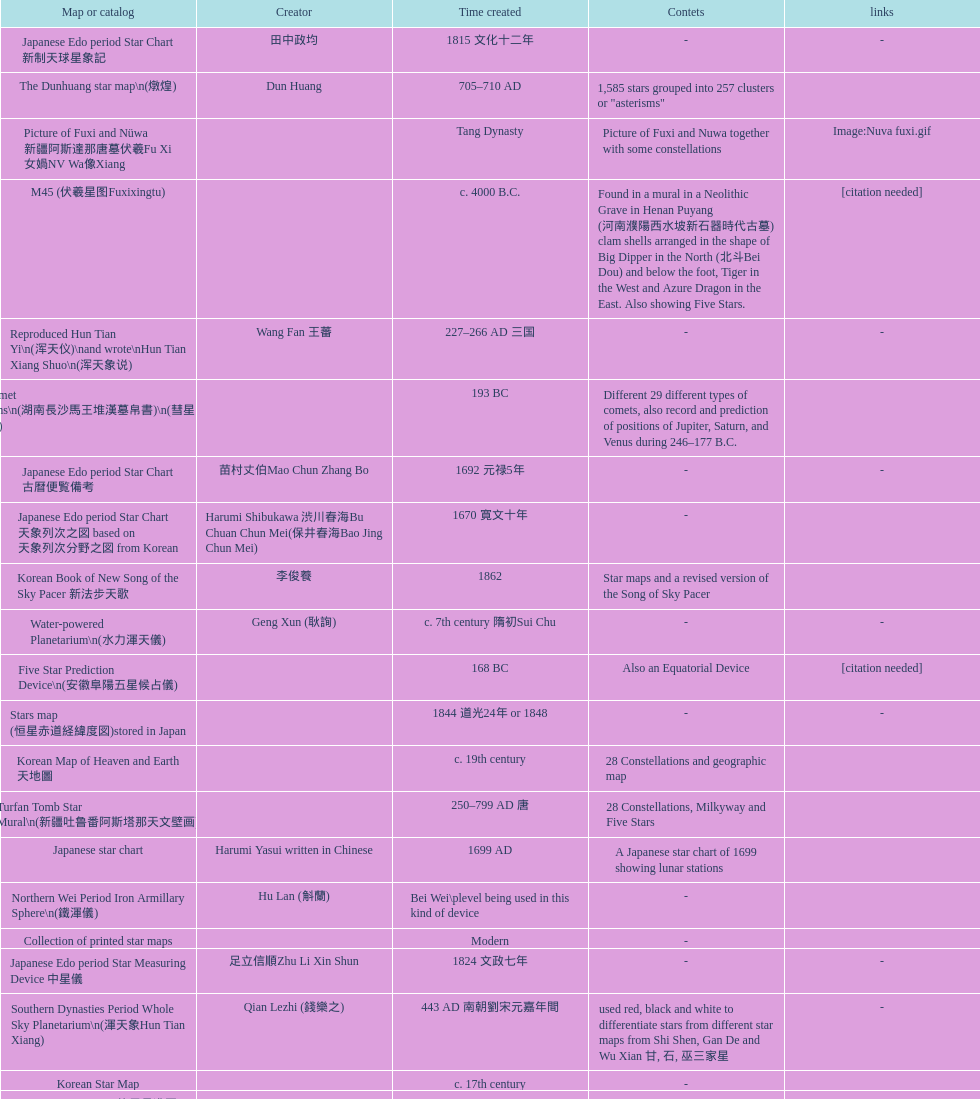Write the full table. {'header': ['Map or catalog', 'Creator', 'Time created', 'Contets', 'links'], 'rows': [['Japanese Edo period Star Chart 新制天球星象記', '田中政均', '1815 文化十二年', '-', '-'], ['The Dunhuang star map\\n(燉煌)', 'Dun Huang', '705–710 AD', '1,585 stars grouped into 257 clusters or "asterisms"', ''], ['Picture of Fuxi and Nüwa 新疆阿斯達那唐墓伏羲Fu Xi 女媧NV Wa像Xiang', '', 'Tang Dynasty', 'Picture of Fuxi and Nuwa together with some constellations', 'Image:Nuva fuxi.gif'], ['M45 (伏羲星图Fuxixingtu)', '', 'c. 4000 B.C.', 'Found in a mural in a Neolithic Grave in Henan Puyang (河南濮陽西水坡新石器時代古墓) clam shells arranged in the shape of Big Dipper in the North (北斗Bei Dou) and below the foot, Tiger in the West and Azure Dragon in the East. Also showing Five Stars.', '[citation needed]'], ['Reproduced Hun Tian Yi\\n(浑天仪)\\nand wrote\\nHun Tian Xiang Shuo\\n(浑天象说)', 'Wang Fan 王蕃', '227–266 AD 三国', '-', '-'], ['Han Comet Diagrams\\n(湖南長沙馬王堆漢墓帛書)\\n(彗星圖Meng xing Tu)', '', '193 BC', 'Different 29 different types of comets, also record and prediction of positions of Jupiter, Saturn, and Venus during 246–177 B.C.', ''], ['Japanese Edo period Star Chart 古暦便覧備考', '苗村丈伯Mao Chun Zhang Bo', '1692 元禄5年', '-', '-'], ['Japanese Edo period Star Chart 天象列次之図 based on 天象列次分野之図 from Korean', 'Harumi Shibukawa 渋川春海Bu Chuan Chun Mei(保井春海Bao Jing Chun Mei)', '1670 寛文十年', '-', ''], ['Korean Book of New Song of the Sky Pacer 新法步天歌', '李俊養', '1862', 'Star maps and a revised version of the Song of Sky Pacer', ''], ['Water-powered Planetarium\\n(水力渾天儀)', 'Geng Xun (耿詢)', 'c. 7th century 隋初Sui Chu', '-', '-'], ['Five Star Prediction Device\\n(安徽阜陽五星候占儀)', '', '168 BC', 'Also an Equatorial Device', '[citation needed]'], ['Stars map (恒星赤道経緯度図)stored in Japan', '', '1844 道光24年 or 1848', '-', '-'], ['Korean Map of Heaven and Earth 天地圖', '', 'c. 19th century', '28 Constellations and geographic map', ''], ['Turfan Tomb Star Mural\\n(新疆吐鲁番阿斯塔那天文壁画)', '', '250–799 AD 唐', '28 Constellations, Milkyway and Five Stars', ''], ['Japanese star chart', 'Harumi Yasui written in Chinese', '1699 AD', 'A Japanese star chart of 1699 showing lunar stations', ''], ['Northern Wei Period Iron Armillary Sphere\\n(鐵渾儀)', 'Hu Lan (斛蘭)', 'Bei Wei\\plevel being used in this kind of device', '-', ''], ['Collection of printed star maps', '', 'Modern', '-', ''], ['Japanese Edo period Star Measuring Device 中星儀', '足立信順Zhu Li Xin Shun', '1824 文政七年', '-', '-'], ['Southern Dynasties Period Whole Sky Planetarium\\n(渾天象Hun Tian Xiang)', 'Qian Lezhi (錢樂之)', '443 AD 南朝劉宋元嘉年間', 'used red, black and white to differentiate stars from different star maps from Shi Shen, Gan De and Wu Xian 甘, 石, 巫三家星', '-'], ['Korean Star Map', '', 'c. 17th century', '-', ''], ['Japanese Star Chart 格子月進図', '', '1324', 'Similar to Su Song Star Chart, original burned in air raids during World War II, only pictures left. Reprinted in 1984 by 佐佐木英治', ''], ['Korean Star Map 天象列次分野之図 in Kanji', '', 'c. 19th century', 'Printed map showing Chinese names of stars and constellations', '[18]'], ['Tangut Khara-Khoto (The Black City) Star Map 西夏黑水城星圖', '', '940 AD', 'A typical Qian Lezhi Style Star Map', '-'], ['Korean Star Map Stone', '', 'c. 17th century', '-', ''], ['Chinese Star map', 'John Reeves esq', '1819 AD', 'Printed map showing Chinese names of stars and constellations', ''], ['Wikipedia Star maps', '', 'Modern', '-', 'zh:華蓋星'], ['Equatorial Armillary Sphere\\n(赤道式渾儀)', 'Luo Xiahong (落下閎)', '104 BC 西漢武帝時', 'lost', '[citation needed]'], ['Korean Book of Stars 經星', '', 'c. 19th century', 'Several star maps', ''], ['Chanshu Star Chart (明常熟石刻天文圖)', '', '1506', 'Based on Suzhou Star Chart, Northern Sky observed at 36.8 degrees North Latitude, 1466 stars grouped into 284 asterism', '-'], ['Ming Dynasty General Star Map (赤道南北兩總星圖)', 'Xu Guang ci 徐光啟 and Adam Schall von Bell Tang Ruo Wang湯若望', '1634', '-', ''], ['The Chinese Sky during the Han Constellating Stars and Society', 'Sun Xiaochun and Jacob Kistemaker', '1997 AD', 'An attempt to recreate night sky seen by Chinese 2000 years ago', ''], ['Song Dynasty Bronze Armillary Sphere 北宋天文院黄道渾儀', 'Shu Yijian 舒易簡, Yu Yuan 于渊, Zhou Cong 周琮', '宋皇祐年中', 'Similar to the Armillary by Tang Dynasty Liang Lingzan 梁令瓚 and Yi Xing 一行', '-'], ['First remark of a constellation in observation in Korean history', '', '49 BC 혁거세 거서간 9년', "The star 'Pae'(a kind of comet) appeared in the constellation Wang Rang", 'Samguk Sagi'], ['Ming Ancient Star Chart 北京隆福寺(古星圖)', '', 'c. 1453 明代', '1420 Stars, possibly based on old star maps from Tang Dynasty', ''], ['Big Dipper\\n(山東嘉祥武梁寺石刻北斗星)', '', '–', 'showing stars in Big Dipper', ''], ['修真內外火侯全圖 Huo Hou Tu', 'Xi Chun Sheng Chong Hui\\p2005 redrawn, original unknown', 'illustrations of Milkyway and star maps, Chinese constellations in Taoism view', '', ''], ['Star Chart 清蒙文石刻(欽天監繪製天文圖) in Mongolia', '', '1727–1732 AD', '1550 stars grouped into 270 starisms.', ''], ['Japanese Edo period Star Chart 天球図', '坂部廣胖', '1816 文化十三年', '-', '-'], ['Korean Tomb', '', 'c. late 14th century', 'Big Dipper', ''], ['Zhou Tian Xuan Ji Tu (周天璇玑图) and He He Si Xiang Tu (和合四象圖) in Xing Ming Gui Zhi (性命圭旨)', 'by 尹真人高第弟子 published by 余永宁', '1615', 'Drawings of Armillary Sphere and four Chinese Celestial Animals with some notes. Related to Taoism.', ''], ['Sky Map\\n(浑天图)\\nand\\nHun Tian Yi Shuo\\n(浑天仪说)', 'Lu Ji (陆绩)', '187–219 AD 三国', '-', '-'], ['Japanese Edo period Star Chart 経緯簡儀用法', '藤岡有貞', '1845 弘化２年', '-', '-'], ['Eastern Han Celestial Globe and star maps\\n(浑天仪)\\n(渾天儀圖注,浑天仪图注)\\n(靈憲,灵宪)', 'Zhang Heng (张衡)', '117 AD', '-', '-'], ['Star Map with illustrations for Xingguans', '坐井★观星Zuo Jing Guan Xing', 'Modern', 'illustrations for cylindrical and circular polar maps', ''], ['28 Xu Star map and catalog', '-', 'Modern', 'Stars around ecliptic', ''], ['Japanese Star Chart 改正天文図説', '', 'unknown', 'Included stars from Harumi Shibukawa', ''], ['Stellarium Chinese and Korean Sky Culture', 'G.S.K. Lee; Jeong, Tae-Min(jtm71); Yu-Pu Wang (evanzxcv)', 'Modern', 'Major Xingguans and Star names', ''], ['Rock Star Chart 清代天文石', '', 'c. 18th century', 'A Star Chart and general Astronomy Text', ''], ['Japanese Edo period Star Chart 天象管鈔 天体図 (天文星象図解)', '長久保赤水', '1824 文政七年', '-', ''], ['Star maps', '', 'Recent', 'Chinese 28 Constellation with Chinese and Japanese captions', ''], ['Ancient Star Map 先天图 by 陈抟Chen Tuan', '', 'c. 11th Chen Tuan 宋Song', 'Perhaps based on studying of Puyong Ancient Star Map', 'Lost'], ['Song Dynasty Water-powered Planetarium 宋代 水运仪象台', 'Su Song 蘇頌 and Han Gonglian 韩公廉', 'c. 11th century', '-', ''], ['Prajvalonisa Vjrabhairava Padvinasa-sri-dharani Scroll found in Japan 熾盛光佛頂大威德銷災吉祥陀羅尼經卷首扉畫', '', '972 AD 北宋開寶五年', 'Chinese 28 Constellations and Western Zodiac', '-'], ['Japanese Edo period Star Chart 方円星図,方圓星図 and 増補分度星図方図', '石坂常堅', '1826b文政9年', '-', '-'], ['Fuxi 64 gua 28 xu wood carving 天水市卦台山伏羲六十四卦二十八宿全图', '', 'modern', '-', '-'], ['HNSKY Korean/Chinese Supplement', 'Jeong, Tae-Min(jtm71)/Chuang_Siau_Chin', 'Modern', 'Korean supplement is based on CheonSangYeulChaBunYaZiDo (B.C.100 ~ A.D.100)', ''], ['First Ecliptic Armillary Sphere\\n(黄道仪Huang Dao Yi)', 'Jia Kui 贾逵', '30–101 AD 东汉永元十五年', '-', '-'], ['Korean Star Maps, North and South to the Eclliptic 黃道南北恒星圖', '', '1742', '-', ''], ['Sky in Google Earth KML', '', 'Modern', 'Attempts to show Chinese Star Maps on Google Earth', ''], ['Hun Tian Yi Tong Xing Xiang Quan Tu, Suzhou Star Chart (蘇州石刻天文圖),淳祐天文図', 'Huang Shang (黃裳)', 'created in 1193, etched to stone in 1247 by Wang Zhi Yuan 王致遠', '1434 Stars grouped into 280 Asterisms in Northern Sky map', ''], ['Reproduction of an ancient device 璇璣玉衡', 'Dai Zhen 戴震', '1723–1777 AD', 'based on ancient record and his own interpretation', 'Could be similar to'], ['AEEA Star maps', '', 'Modern', 'Good reconstruction and explanation of Chinese constellations', ''], ['Japanese Star Chart 梅園星図', '高橋景保', '-', '-', ''], ['Warring States Period grave lacquer box\\n(戰國初年湖北隨縣擂鼓墩曾侯乙墓漆箱)', '', 'c. 5th century BC', 'Indicated location of Big Dipper and 28 Constellations by characters', ''], ['Japanese Star Chart', '伊能忠誨', 'c. 19th century', '-', '-'], ['Whole Sky Star Maps\\n(全天星圖Quan Tian Xing Tu)', 'Chen Zhuo (陳卓)', 'c. 270 AD 西晉初Xi Jin Chu', 'A Unified Constellation System. Star maps containing 1464 stars in 284 Constellations, written astrology text', '-'], ['Japanese Edo period Star Chart 天文成象Tian Wen Cheng xiang', '(渋川昔尹She Chuan Xi Yin) (保井昔尹Bao Jing Xi Yin)', '1699 元禄十二年', 'including Stars from Wu Shien (44 Constellation, 144 stars) in yellow; Gan De (118 Constellations, 511 stars) in black; Shi Shen (138 Constellations, 810 stars) in red and Harumi Shibukawa (61 Constellations, 308 stars) in blue;', ''], ['Japanese Star Chart 瀧谷寺 天之図', '', 'c. 14th or 15th centuries 室町中期以前', '-', ''], ['Stars South of Equator, Stars North of Equator (赤道南恆星圖,赤道北恆星圖)', '', '1875～1908 清末光緒年間', 'Similar to Ming Dynasty General Star Map', ''], ['Shi Shen astronomy\\n(石申天文Shi Shen Tian wen)\\naka. (石氏星经 Shi Shi Xing Jing)', 'Shi Shen (石申)', 'c. 350 B.C.', '138 Constellations and the name of 810 stars, location of 121 stars, some said it contains The 28 Lunar Ecliptic Constellations, 62 Central Constellations and 30 Outer Constellations', '[citation needed]'], ['Han Grave Mural Star Chart\\n(洛阳西汉墓壁画)\\n(星象图Xing Xiang Tu)', '', 'c. 1st century', 'Sun, Moon and ten other star charts', ''], ['Five Star Charts (新儀象法要)', 'Su Song 蘇頌', '1094 AD', '1464 stars grouped into 283 asterisms', 'Image:Su Song Star Map 1.JPG\\nImage:Su Song Star Map 2.JPG'], ['Sky Map', 'Yu Xi Dao Ren 玉溪道人', '1987', 'Star Map with captions', ''], ['Ming Dynasty Star Map (渾蓋通憲圖說)', 'Matteo Ricci 利玛窦Li Ma Dou, recorded by Li Zhizao 李之藻', 'c. 1550', '-', ''], ['Japanese Edo period Star Chart 昊天図説詳解', '佐藤祐之', '1824 文政七年', '-', '-'], ['Korean version of 28 Constellation 列宿圖', '', 'c. 19th century', '28 Constellations, some named differently from their Chinese counterparts', ''], ['Korean Complete Star Map (渾天全圖)', '', 'c. 18th century', '-', ''], ['Yuan Dynasty Simplified Armillary Sphere 元代簡儀', 'Guo Shou Jing 郭守敬', '1276–1279', 'Further simplied version of Song Dynasty Device', ''], ['Qing Dynasty Star Catalog (儀象考成,仪象考成)恒星表 and Star Map 黄道南北両星総図', 'Yun Lu 允禄 and Ignatius Kogler 戴进贤Dai Jin Xian 戴進賢, a German', 'Device made in 1744, book completed in 1757 清乾隆年间', '300 Constellations and 3083 Stars. Referenced Star Catalogue published by John Flamsteed', ''], ['SinoSky Beta 2.0', '', '2002', 'A computer program capable of showing Chinese Xingguans alongside with western constellations, lists about 700 stars with Chinese names.', ''], ['Wu Xian Star Map\\n(商巫咸星圖Shang wu Jian xing Tu)', 'Wu Xian', 'c. 1000 BC', 'Contained 44 Central and Outer constellations totalling 141 stars', '[citation needed]'], ['Lingtai Miyuan\\n(靈台秘苑)', 'Yu Jicai (庾季才) and Zhou Fen (周墳)', '604 AD 隋Sui', 'incorporated star maps from different sources', '-'], ['Korean Astronomy Book "Selected and Systematized Astronomy Notes" 天文類抄', '', '1623~1649', 'Contained some star maps', ''], ['Equatorial Armillary Sphere\\n(渾儀Hun Xi)', 'Kong Ting (孔挺)', '323 AD 東晉 前趙光初六年', 'level being used in this kind of device', '-'], ['Star Chart in a Dao Temple 玉皇山道觀星圖', '', '1940 AD', '-', '-'], ['Japanese Edo period Star Chart', '鈴木世孝', '1824 文政七年', '-', '-'], ['Korean star map in stone', '', '1687', '-', ''], ['Star Chart 五代吳越文穆王前元瓘墓石刻星象圖', '', '941–960 AD', '-', ''], ['Japanese Edo period Star Chart 天経或問註解図巻\u3000下', '入江脩敬Ru Jiang YOu Jing', '1750 寛延3年', '-', '-'], ['Japanese Star Map 天象一覧図 in Kanji', '桜田虎門', '1824 AD 文政７年', 'Printed map showing Chinese names of stars and constellations', ''], ['Japanese Edo period Star Chart 星図歩天歌', '小島好謙 and 鈴木世孝', '1824 文政七年', '-', '-'], ['Qing Dynasty Star Catalog (儀象考成續編)星表', '', '1844', 'Appendix to Yi Xian Kao Cheng, listed 3240 stars (added 163, removed 6)', ''], ['Northern Wei Grave Dome Star Map\\n(河南洛陽北魏墓頂星圖)', '', '526 AD 北魏孝昌二年', 'about 300 stars, including the Big Dipper, some stars are linked by straight lines to form constellation. The Milky Way is also shown.', ''], ['Japanese Edo period Star Chart 分野星図', '高塚福昌, 阿部比輔, 上条景弘', '1849 嘉永2年', '-', '-'], ['Japanese Edo period Illustration of a Star Measuring Device 平天儀図解', 'Yan Qiao Shan Bing Heng 岩橋善兵衛', '1802 Xiang He Er Nian 享和二年', '-', 'The device could be similar to'], ['Kitora Kofun 法隆寺FaLong Si\u3000キトラ古墳 in Japan', '', 'c. late 7th century – early 8th century', 'Detailed whole sky map', ''], ['Han Dynasty Nanyang Stone Engraving\\n(河南南阳汉石刻画)\\n(行雨图Xing Yu Tu)', '', 'c. 1st century', 'Depicted five stars forming a cross', ''], ['天象列次分野之図(Cheonsang Yeolcha Bunyajido)', '', '1395', 'Korean versions of Star Map in Stone. It was made in Chosun Dynasty and the constellation names were written in Chinese letter. The constellations as this was found in Japanese later. Contained 1,464 stars.', ''], ['Tang Dynasty Whole Sky Ecliptic Armillary Sphere\\n(渾天黃道儀)', 'Li Chunfeng 李淳風', '667 AD 貞觀七年', 'including Elliptic and Moon orbit, in addition to old equatorial design', '-'], ['Ming Dynasty Planetarium Machine (渾象 Hui Xiang)', '', 'c. 17th century', 'Ecliptic, Equator, and dividers of 28 constellation', ''], ['Jingban Tianwen Quantu by Ma Junliang 马俊良', '', '1780–90 AD', 'mapping nations to the sky', ''], ['Korean Star Map Cube 方星圖', 'Italian Missionary Philippus Maria Grimardi 閔明我 (1639~1712)', 'c. early 18th century', '-', ''], ['North Sky Map 清嘉庆年间Huang Dao Zhong Xi He Tu(黄道中西合图)', 'Xu Choujun 徐朝俊', '1807 AD', 'More than 1000 stars and the 28 consellation', ''], ['Japanese Late Edo period Star Chart 天文図屏風', '遠藤盛俊', 'late Edo Period 江戸時代後期', '-', '-'], ['Japanese Star Chart 天体図', '三浦梅園', '-', '-', '-'], ['Korean Star maps: Star Map South to the Ecliptic 黃道南恒星圖 and Star Map South to the Ecliptic 黃道北恒星圖', '', 'c. 19th century', 'Perhaps influenced by Adam Schall von Bell Tang Ruo wang 湯若望 (1591–1666) and P. Ignatius Koegler 戴進賢 (1680–1748)', ''], ["Star Map in a woman's grave (江西德安 南宋周氏墓星相图)", '', '1127–1279 AD', 'Milky Way and 57 other stars.', ''], ['Song Dynasty Bronze Armillary Sphere 北宋至道銅渾儀', 'Han Xianfu 韓顯符', '1006 AD 宋道元年十二月', 'Similar to the Simplified Armillary by Kong Ting 孔挺, 晁崇 Chao Chong, 斛蘭 Hu Lan', '-'], ['Star Chart preserved in Japan based on a book from China 天経或問', 'You Zi liu 游子六', '1730 AD 江戸時代 享保15年', 'A Northern Sky Chart in Chinese', ''], ['Treatise on Astrology of the Kaiyuan Era\\n(開元占経,开元占经Kai Yuan zhang Jing)', 'Gautama Siddha', '713 AD –', 'Collection of the three old star charts from Shi Shen, Gan De and Wu Xian. One of the most renowned collection recognized academically.', '-'], ['Liao Dynasty Tomb Dome Star Map 遼宣化张世卿墓頂星圖', '', '1116 AD 遼天庆六年', 'shown both the Chinese 28 Constellation encircled by Babylonian Zodiac', ''], ['Korean Star Chart 渾天図', '朴?', '-', '-', '-'], ['Tang Dynasty Indian Horoscope Chart\\n(梵天火羅九曜)', 'Yixing Priest 一行和尚 (张遂)\\pZhang Sui\\p683–727 AD', 'simple diagrams of the 28 Constellation', '', ''], ['Song Dynasty Armillary Sphere 北宋簡化渾儀', 'Shen Kuo 沈括 and Huangfu Yu 皇甫愈', '1089 AD 熙寧七年', 'Simplied version of Tang Dynasty Device, removed the rarely used moon orbit.', '-'], ['Tian Wun Tu (天问图)', 'Xiao Yun Cong 萧云从', 'c. 1600', 'Contained mapping of 12 constellations and 12 animals', ''], ['The Celestial Globe 清康熙 天體儀', 'Ferdinand Verbiest 南懷仁', '1673', '1876 stars grouped into 282 asterisms', ''], ['Celestial Globe\\n(渾象)\\n(圓儀)', 'Geng Shouchang (耿壽昌)', '52 BC 甘露二年Gan Lu Er Ren', 'lost', '[citation needed]'], ['Star map', '', 'Recent', 'An attempt by a Japanese to reconstruct the night sky for a historical event around 235 AD 秋風五丈原', ''], ['Korean Star Map', '', 'c. 19th century, late Choson Period', '-', ''], ['Ceramic Ink Sink Cover', '', 'c. 17th century', 'Showing Big Dipper', ''], ['Copper Plate Star Map stored in Korea', '', '1652 順治九年shun zi jiu nian', '-', ''], ['28 Constellations, big dipper and 4 symbols Star map', '', 'Modern', '-', ''], ['Picture depicted Song Dynasty fictional astronomer (呉用 Wu Yong) with a Celestial Globe (天體儀)', 'Japanese painter', '1675', 'showing top portion of a Celestial Globe', 'File:Chinese astronomer 1675.jpg'], ['Korean Complete map of the celestial sphere (渾天全圖)', '', 'c. 19th century', '-', ''], ["Korean King Sejong's Armillary sphere", '', '1433', '-', ''], ['Japanese Edo period Star Chart 天文図解', '井口常範', '1689 元禄2年', '-', '-'], ['Japanese Edo period Star Chart 天文分野之図', 'Harumi Shibukawa 渋川春海BuJingChun Mei (保井春海Bao JingChunMei)', '1677 延宝五年', '-', ''], ['Astronomic star observation\\n(天文星占Tian Wen xing zhan)', 'Gan De (甘德)', '475-221 B.C.', 'Contained 75 Central Constellation and 42 Outer Constellations, some said 510 stars in 18 Constellations', '[citation needed]'], ['Ming Dynasty diagrams of Armillary spheres and Celestial Globes', 'Xu Guang ci 徐光啟', 'c. 1699', '-', ''], ['Simplified Chinese and Western Star Map', 'Yi Shi Tong 伊世同', 'Aug. 1963', 'Star Map showing Chinese Xingquan and Western Constellation boundaries', ''], ['Japanese Edo period Star Chart 天球図説', '古筆源了材', '1835 天保6年', '-', '-'], ['Tang Dynasty Armillary Sphere\\n(唐代渾儀Tang Dai Hun Xi)\\n(黃道遊儀Huang dao you xi)', 'Yixing Monk 一行和尚 (张遂)Zhang Sui and Liang Lingzan 梁令瓚', '683–727 AD', 'based on Han Dynasty Celestial Globe, recalibrated locations of 150 stars, determined that stars are moving', ''], ['Star Chart', 'Mao Kun 茅坤', 'c. 1422', 'Polaris compared with Southern Cross and Alpha Centauri', 'zh:郑和航海图'], ['Japanese Edo period Star Chart 天象総星之図', 'Chao Ye Bei Shui 朝野北水', '1814 文化十一年', '-', '-']]} Did xu guang ci or su song create the five star charts in 1094 ad? Su Song 蘇頌. 